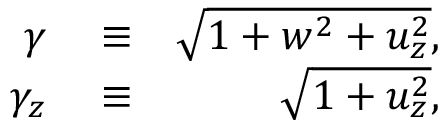<formula> <loc_0><loc_0><loc_500><loc_500>\begin{array} { r l r } { \gamma } & \equiv } & { \sqrt { 1 + w ^ { 2 } + u _ { z } ^ { 2 } } , } \\ { \gamma _ { z } } & \equiv } & { \sqrt { 1 + u _ { z } ^ { 2 } } , } \end{array}</formula> 